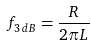Convert formula to latex. <formula><loc_0><loc_0><loc_500><loc_500>f _ { 3 \, d B } = { \frac { R } { 2 \pi L } }</formula> 